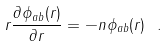<formula> <loc_0><loc_0><loc_500><loc_500>r \frac { \partial \phi _ { a b } ( r ) } { \partial r } = - n \phi _ { a b } ( r ) \ .</formula> 